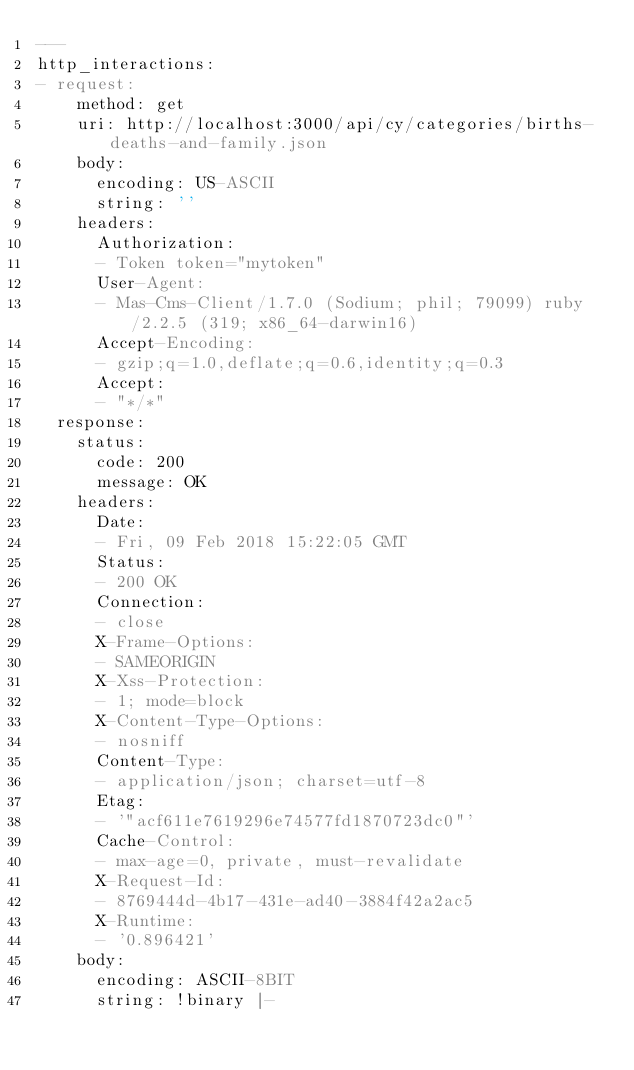<code> <loc_0><loc_0><loc_500><loc_500><_YAML_>---
http_interactions:
- request:
    method: get
    uri: http://localhost:3000/api/cy/categories/births-deaths-and-family.json
    body:
      encoding: US-ASCII
      string: ''
    headers:
      Authorization:
      - Token token="mytoken"
      User-Agent:
      - Mas-Cms-Client/1.7.0 (Sodium; phil; 79099) ruby/2.2.5 (319; x86_64-darwin16)
      Accept-Encoding:
      - gzip;q=1.0,deflate;q=0.6,identity;q=0.3
      Accept:
      - "*/*"
  response:
    status:
      code: 200
      message: OK
    headers:
      Date:
      - Fri, 09 Feb 2018 15:22:05 GMT
      Status:
      - 200 OK
      Connection:
      - close
      X-Frame-Options:
      - SAMEORIGIN
      X-Xss-Protection:
      - 1; mode=block
      X-Content-Type-Options:
      - nosniff
      Content-Type:
      - application/json; charset=utf-8
      Etag:
      - '"acf611e7619296e74577fd1870723dc0"'
      Cache-Control:
      - max-age=0, private, must-revalidate
      X-Request-Id:
      - 8769444d-4b17-431e-ad40-3884f42a2ac5
      X-Runtime:
      - '0.896421'
    body:
      encoding: ASCII-8BIT
      string: !binary |-</code> 